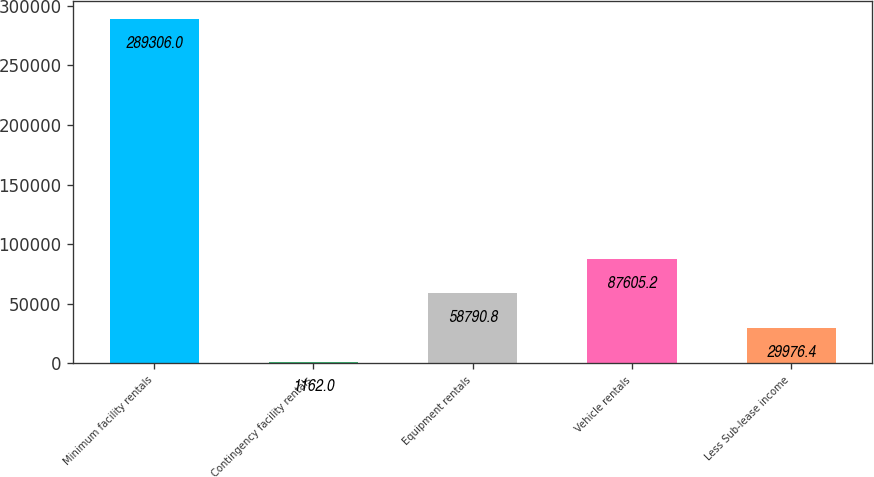Convert chart to OTSL. <chart><loc_0><loc_0><loc_500><loc_500><bar_chart><fcel>Minimum facility rentals<fcel>Contingency facility rentals<fcel>Equipment rentals<fcel>Vehicle rentals<fcel>Less Sub-lease income<nl><fcel>289306<fcel>1162<fcel>58790.8<fcel>87605.2<fcel>29976.4<nl></chart> 